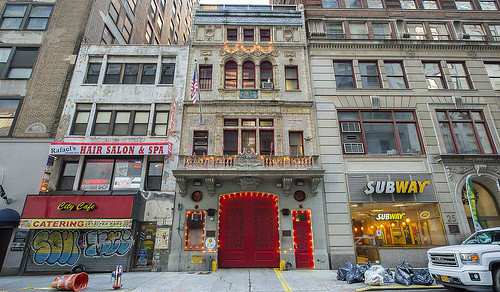<image>
Can you confirm if the car is under the building? Yes. The car is positioned underneath the building, with the building above it in the vertical space. Is the car in the building? No. The car is not contained within the building. These objects have a different spatial relationship. 